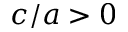Convert formula to latex. <formula><loc_0><loc_0><loc_500><loc_500>c / a > 0</formula> 